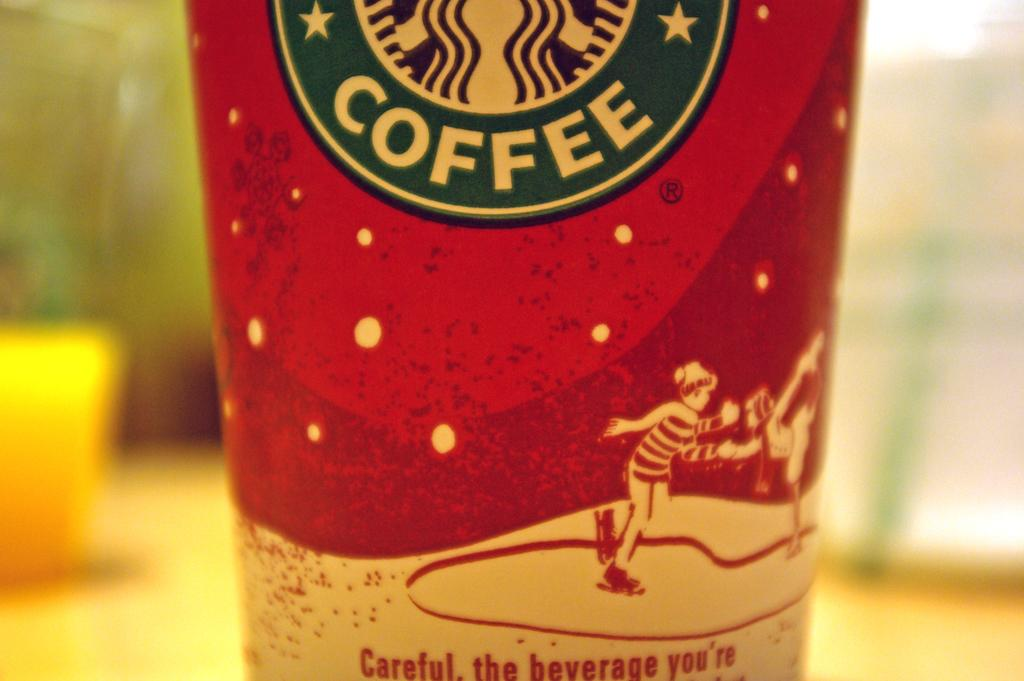Provide a one-sentence caption for the provided image. A closeup of a Starbucks coffee cup that says "Careful". 